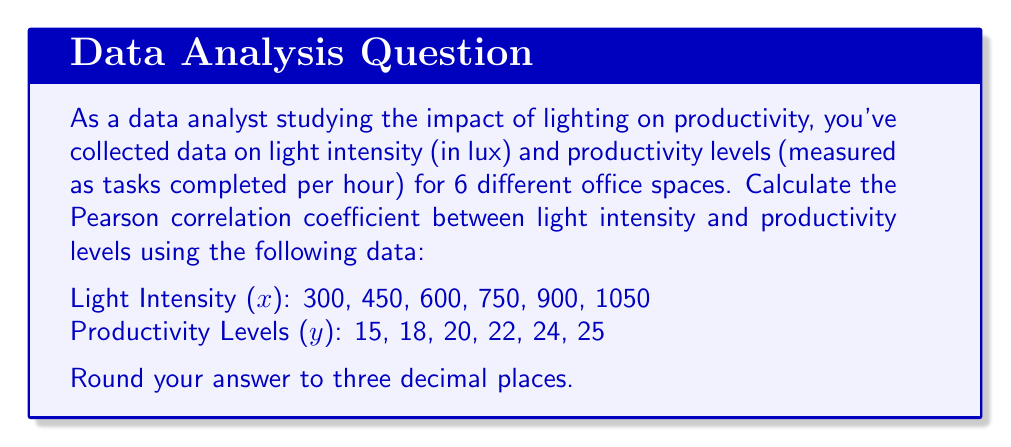Show me your answer to this math problem. To calculate the Pearson correlation coefficient (r), we'll use the formula:

$$ r = \frac{n\sum xy - \sum x \sum y}{\sqrt{[n\sum x^2 - (\sum x)^2][n\sum y^2 - (\sum y)^2]}} $$

Where n is the number of data points.

Step 1: Calculate the sums and squared sums:
$n = 6$
$\sum x = 300 + 450 + 600 + 750 + 900 + 1050 = 4050$
$\sum y = 15 + 18 + 20 + 22 + 24 + 25 = 124$
$\sum xy = (300 \times 15) + (450 \times 18) + ... + (1050 \times 25) = 86,100$
$\sum x^2 = 300^2 + 450^2 + ... + 1050^2 = 3,037,500$
$\sum y^2 = 15^2 + 18^2 + ... + 25^2 = 2,590$

Step 2: Calculate the numerator:
$n\sum xy - \sum x \sum y = 6(86,100) - 4050(124) = 16,200$

Step 3: Calculate the denominator:
$\sqrt{[n\sum x^2 - (\sum x)^2][n\sum y^2 - (\sum y)^2]}$
$= \sqrt{[6(3,037,500) - 4050^2][6(2,590) - 124^2]}$
$= \sqrt{(855,000)(404)} = 18,572.16$

Step 4: Divide the numerator by the denominator:
$r = \frac{16,200}{18,572.16} = 0.87228$

Step 5: Round to three decimal places:
$r \approx 0.872$
Answer: 0.872 